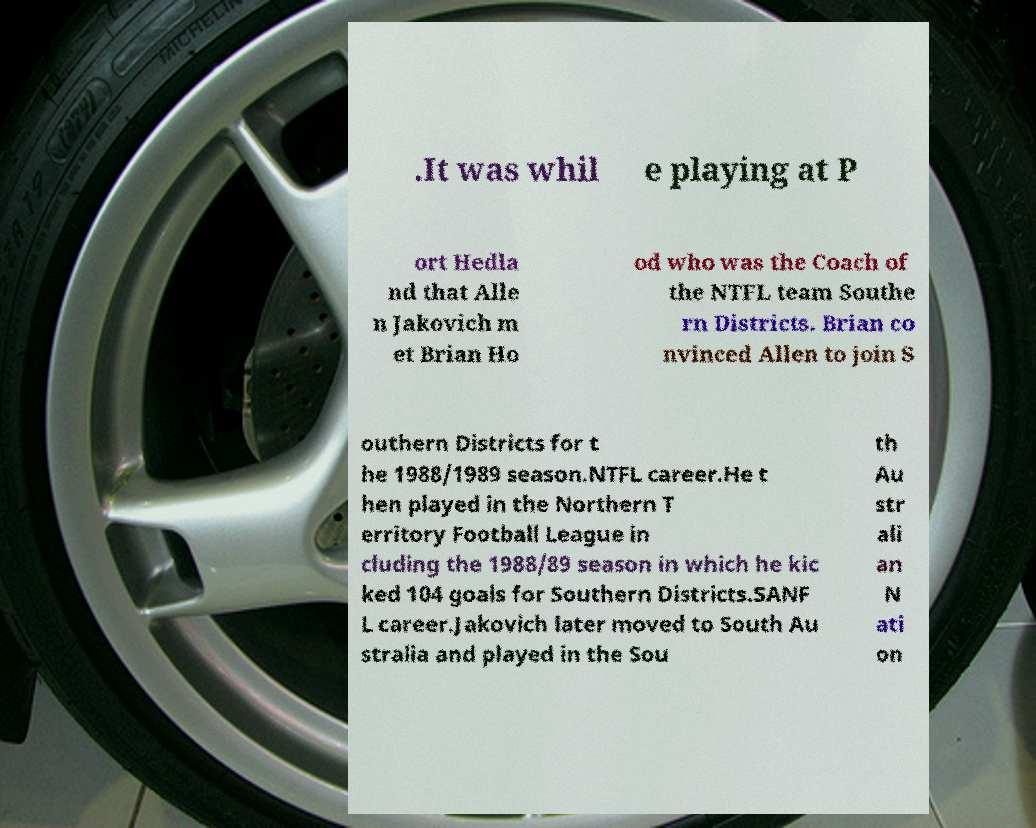I need the written content from this picture converted into text. Can you do that? .It was whil e playing at P ort Hedla nd that Alle n Jakovich m et Brian Ho od who was the Coach of the NTFL team Southe rn Districts. Brian co nvinced Allen to join S outhern Districts for t he 1988/1989 season.NTFL career.He t hen played in the Northern T erritory Football League in cluding the 1988/89 season in which he kic ked 104 goals for Southern Districts.SANF L career.Jakovich later moved to South Au stralia and played in the Sou th Au str ali an N ati on 